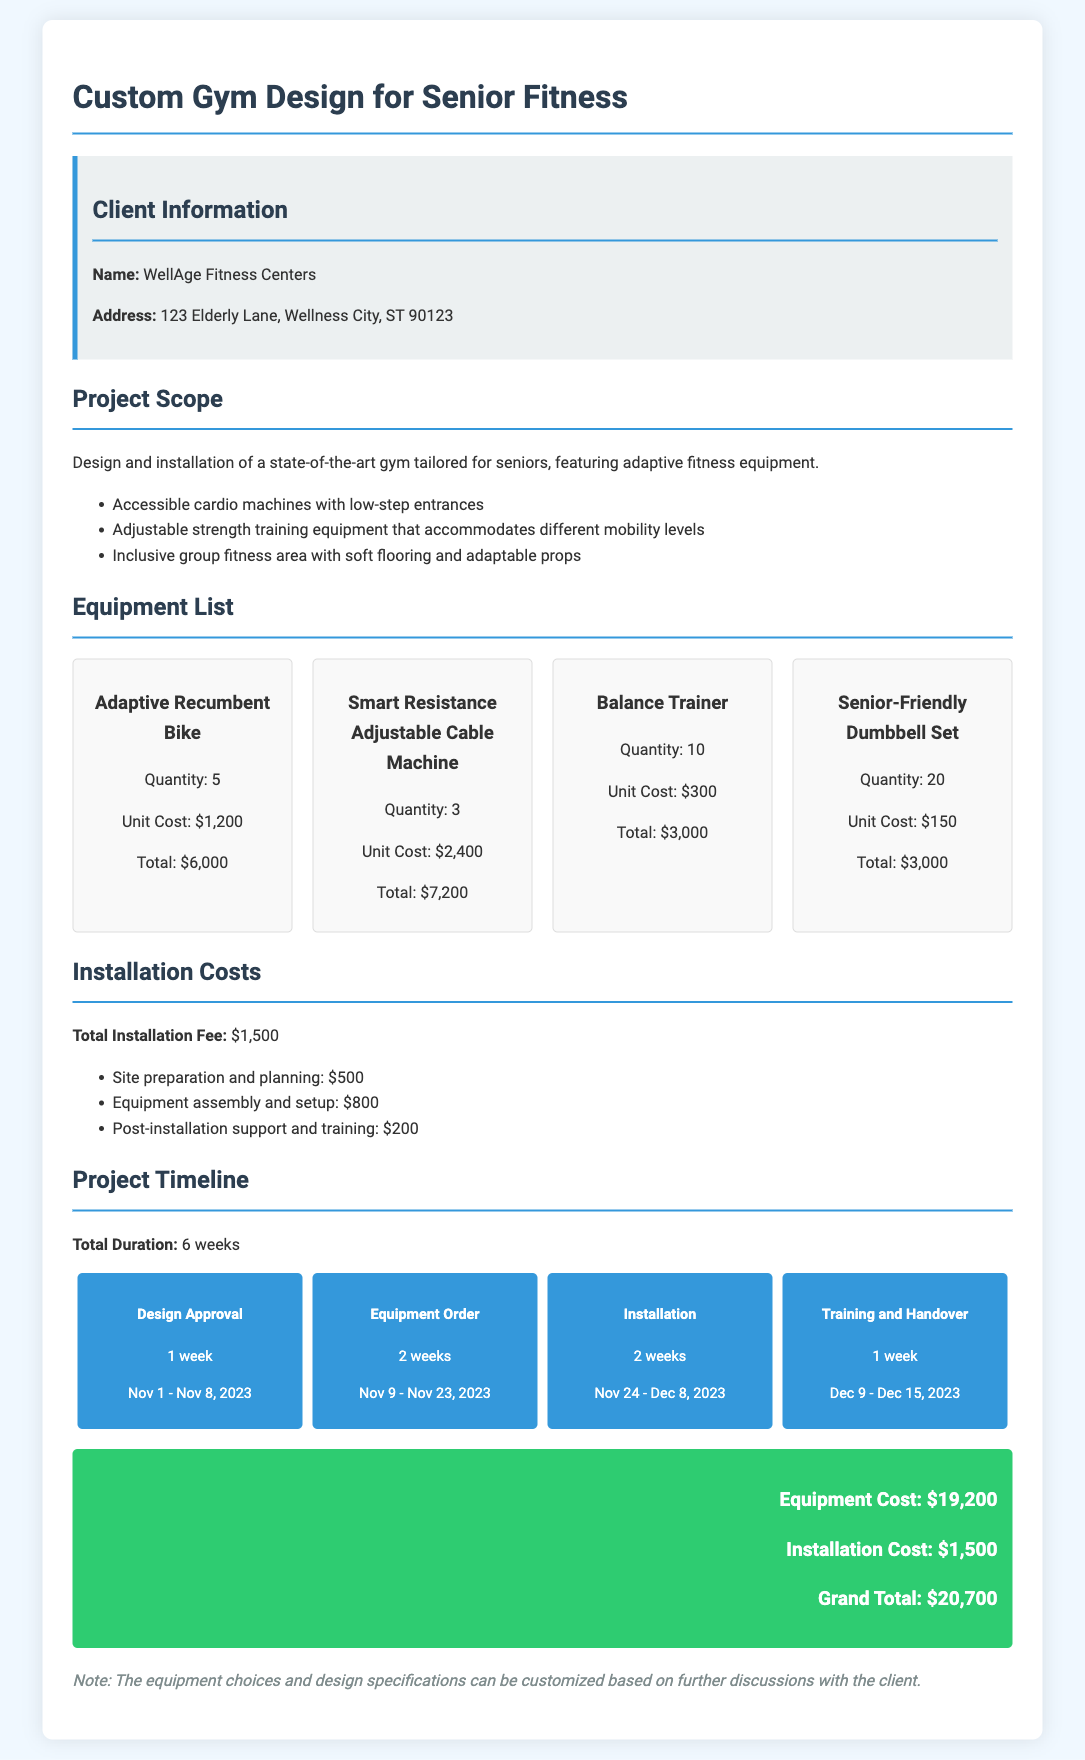What is the name of the client? The client's name is specified in the client information section of the document.
Answer: WellAge Fitness Centers What is the total equipment cost? The total equipment cost is calculated from the sum of all equipment listed in the equipment section.
Answer: $19,200 How many Adaptive Recumbent Bikes are included? The quantity of Adaptive Recumbent Bikes is mentioned under the Equipment List section.
Answer: 5 What is the total duration of the project? The total duration can be found in the Project Timeline section, summarizing the project phases.
Answer: 6 weeks How much is the total installation fee? The total installation fee is provided in the Installation Costs section of the document.
Answer: $1,500 What is the timeline phase for design approval? The timeline phase for design approval includes specific weeks and dates mentioned in the Project Timeline.
Answer: Nov 1 - Nov 8, 2023 How many weeks are allocated for equipment ordering? The project timeline includes a specific time frame for equipment ordering, which is mentioned directly.
Answer: 2 weeks What is the grand total cost of the project? The grand total cost is the sum of equipment cost and installation cost listed at the bottom of the document.
Answer: $20,700 What kind of fitness area is included in the design? The type of fitness area is outlined under the Project Scope section, defining its features.
Answer: Inclusive group fitness area 